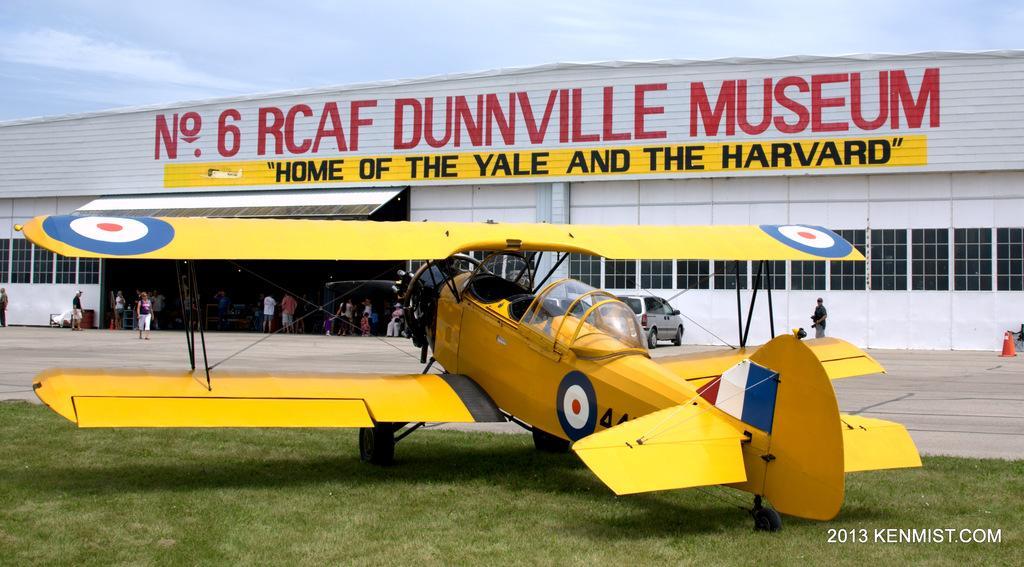Describe this image in one or two sentences. In the foreground of the picture there is a plane in the grass. In the center of the picture it is runway. In the center of the background there is a shed, inside the shed there are people. Sky is clear and it is sunny. 